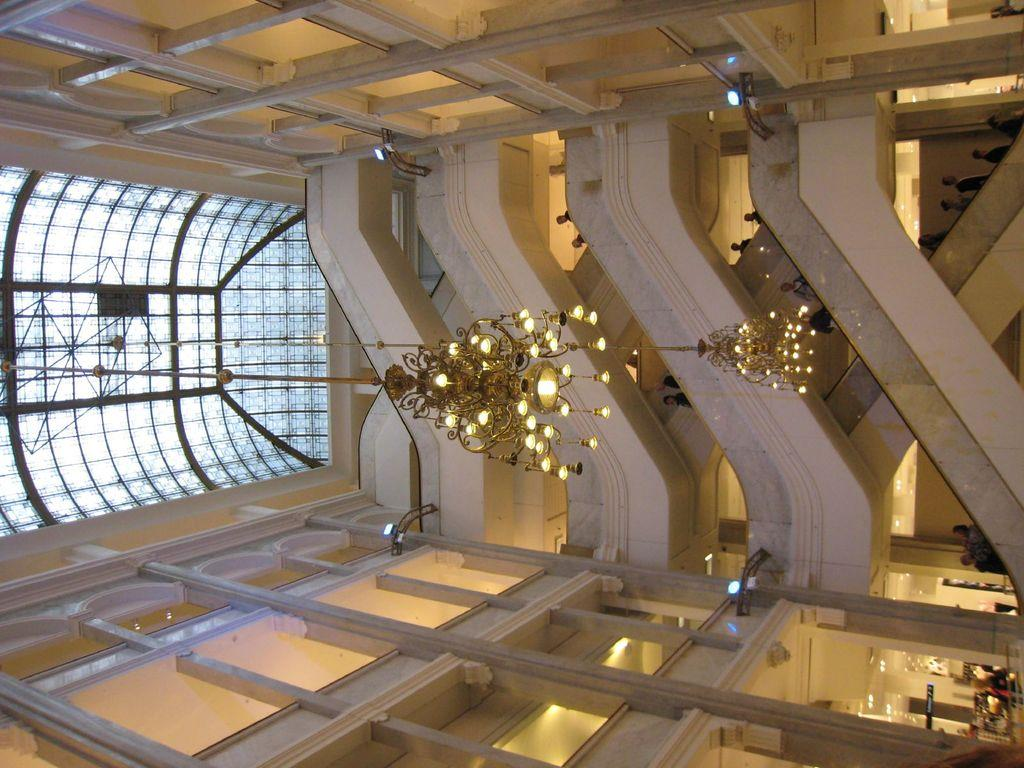What type of view does the image provide? The image provides an inside view of a building. What architectural feature can be seen at the front of the image? There are steps in the front of the image. What type of lighting is present in the image? Hanging chandeliers are visible in the image. What is the structure of the roof in the image? There is a glass roof at the top of the image. What type of voice can be heard in the image? There is no voice present in the image. The image is a still photograph, and voices are not visible in photographs. 